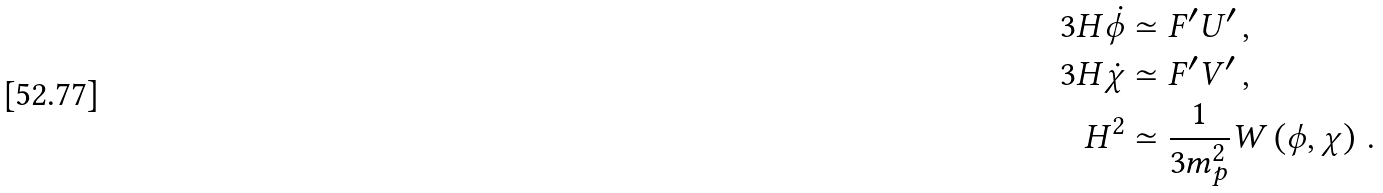Convert formula to latex. <formula><loc_0><loc_0><loc_500><loc_500>3 H \dot { \phi } & \simeq F ^ { \prime } U ^ { \prime } \, , \\ 3 H \dot { \chi } & \simeq F ^ { \prime } V ^ { \prime } \, , \\ H ^ { 2 } & \simeq \frac { 1 } { 3 m _ { p } ^ { 2 } } W \left ( \phi , \chi \right ) \, .</formula> 